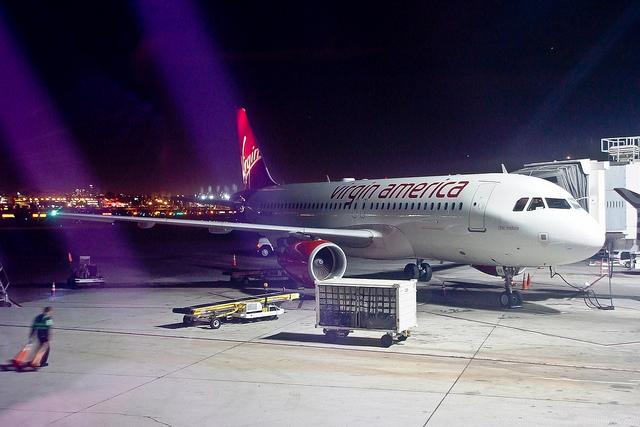What is the name of the plane?
Concise answer only. Virgin america. Is the plane white and red?
Give a very brief answer. Yes. What are color are the two streams of light?
Answer briefly. Purple. Is this an express flight?
Concise answer only. No. 